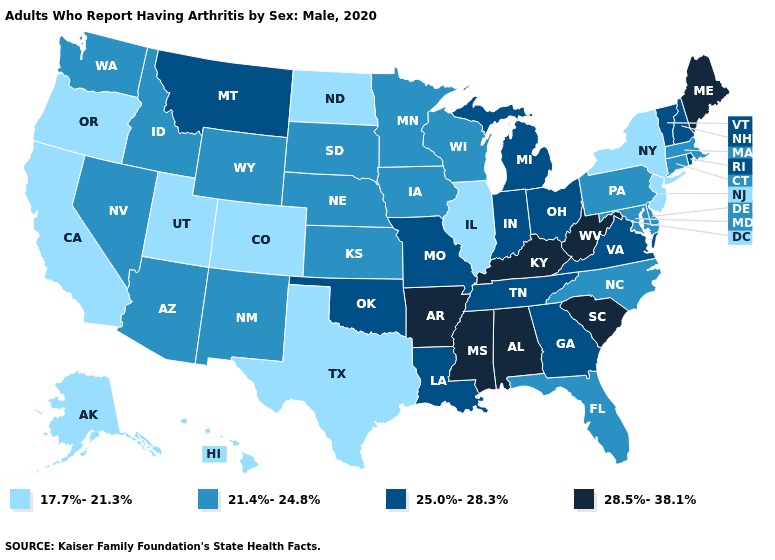Among the states that border Minnesota , which have the lowest value?
Short answer required. North Dakota. Name the states that have a value in the range 25.0%-28.3%?
Keep it brief. Georgia, Indiana, Louisiana, Michigan, Missouri, Montana, New Hampshire, Ohio, Oklahoma, Rhode Island, Tennessee, Vermont, Virginia. Name the states that have a value in the range 25.0%-28.3%?
Concise answer only. Georgia, Indiana, Louisiana, Michigan, Missouri, Montana, New Hampshire, Ohio, Oklahoma, Rhode Island, Tennessee, Vermont, Virginia. Name the states that have a value in the range 21.4%-24.8%?
Quick response, please. Arizona, Connecticut, Delaware, Florida, Idaho, Iowa, Kansas, Maryland, Massachusetts, Minnesota, Nebraska, Nevada, New Mexico, North Carolina, Pennsylvania, South Dakota, Washington, Wisconsin, Wyoming. Does Oregon have the same value as New York?
Give a very brief answer. Yes. Among the states that border Iowa , does Nebraska have the highest value?
Keep it brief. No. What is the value of Iowa?
Keep it brief. 21.4%-24.8%. Name the states that have a value in the range 28.5%-38.1%?
Concise answer only. Alabama, Arkansas, Kentucky, Maine, Mississippi, South Carolina, West Virginia. What is the lowest value in the USA?
Give a very brief answer. 17.7%-21.3%. What is the value of Wyoming?
Be succinct. 21.4%-24.8%. Among the states that border Nebraska , which have the highest value?
Give a very brief answer. Missouri. Does Utah have the same value as New Jersey?
Write a very short answer. Yes. What is the value of New Jersey?
Answer briefly. 17.7%-21.3%. Does Ohio have the same value as Georgia?
Quick response, please. Yes. Does Pennsylvania have a lower value than Ohio?
Quick response, please. Yes. 